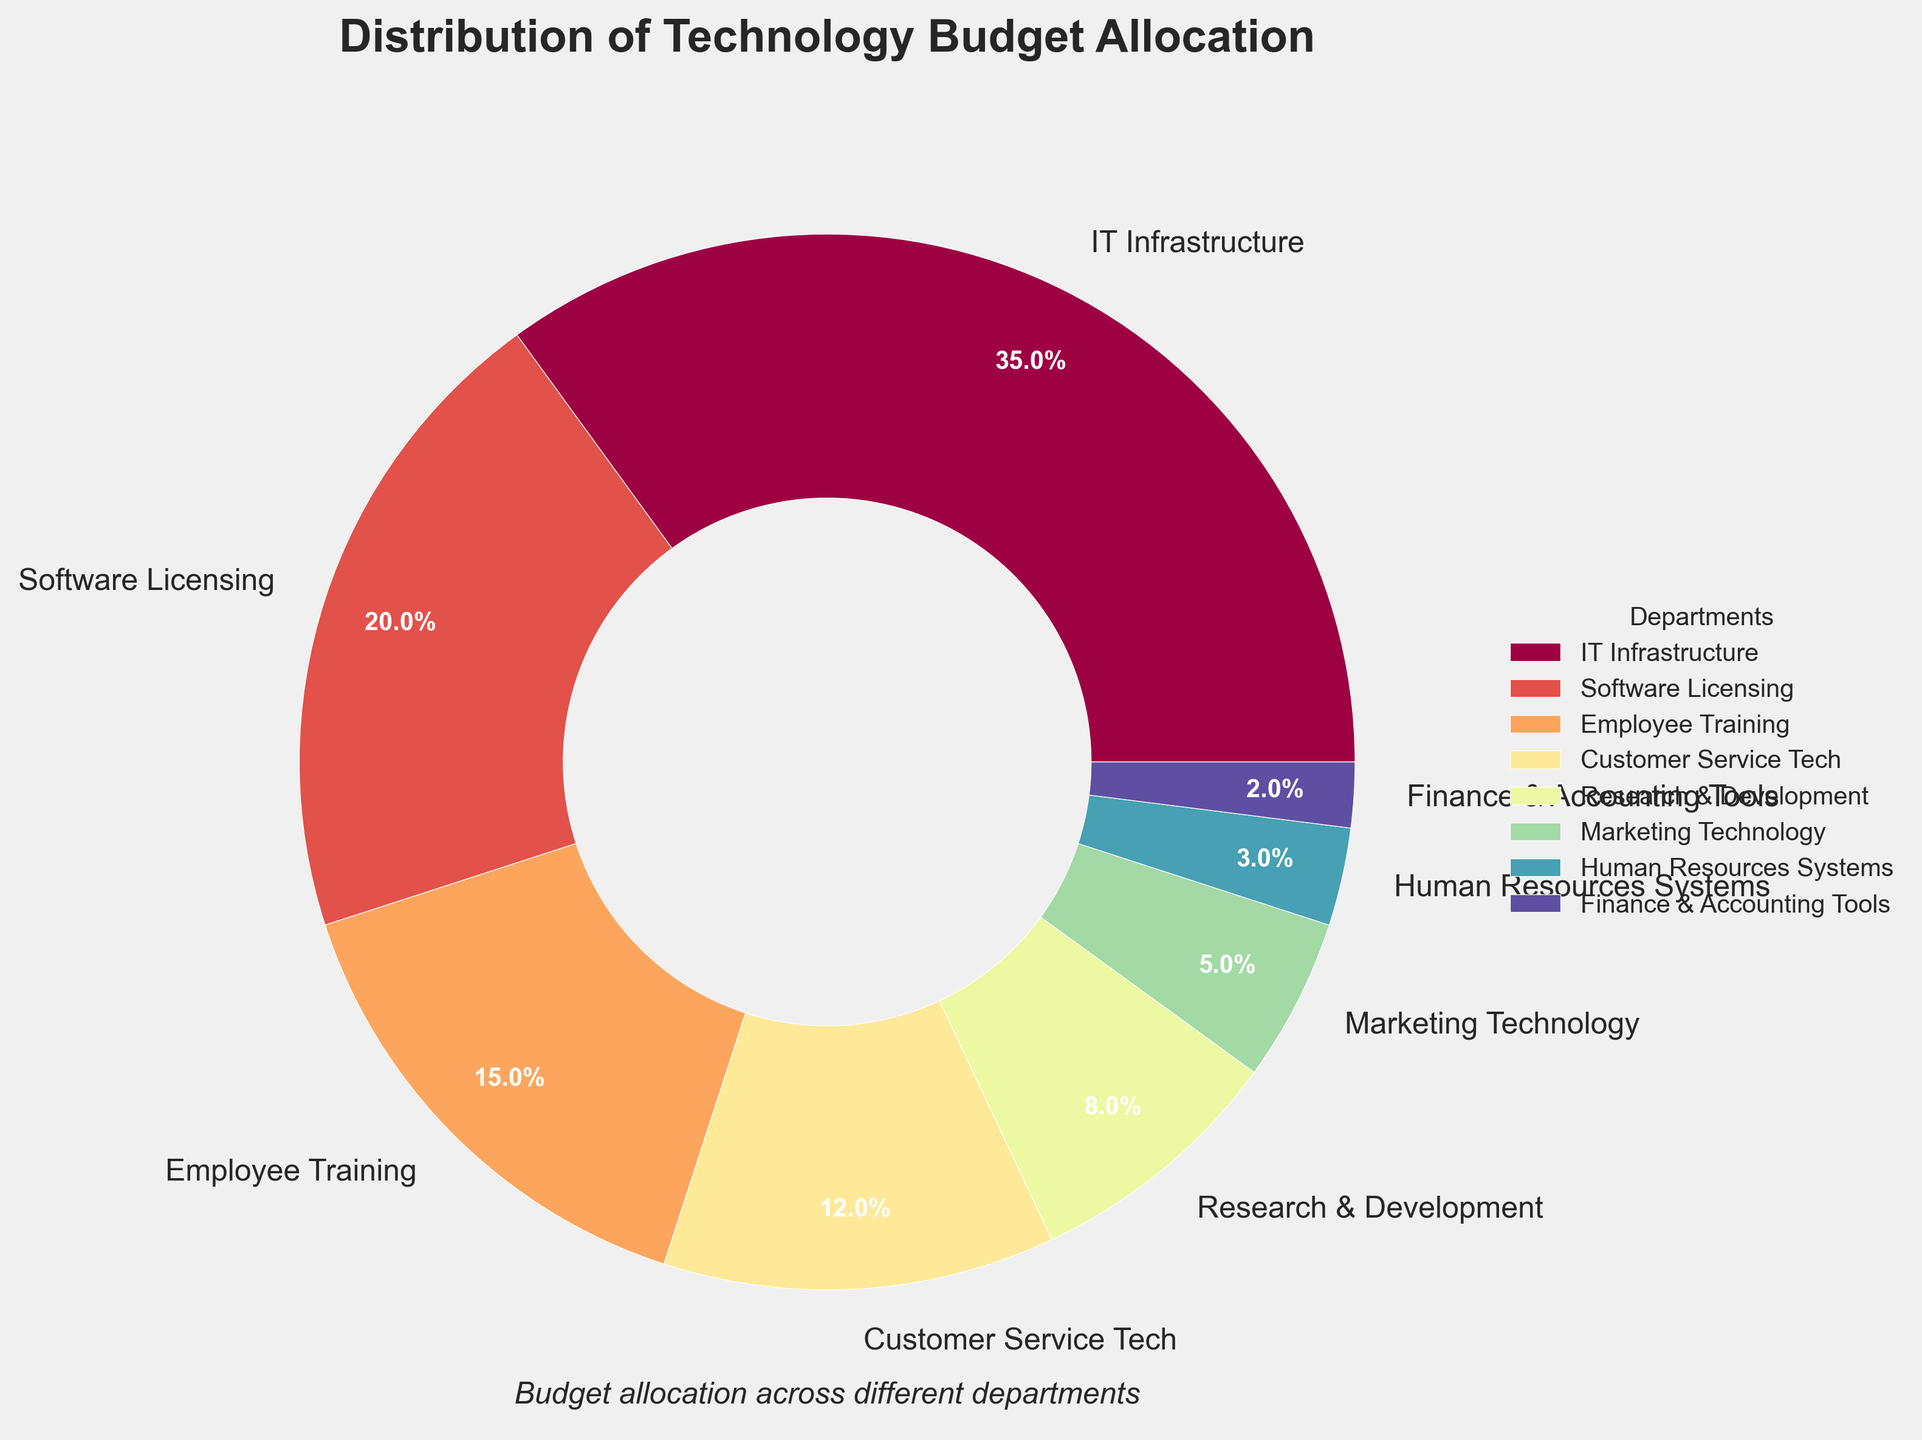What percentage of the budget is allocated to IT Infrastructure? The pie chart shows the budget allocation for each department, with the percentage values labeled on each section. According to the chart, IT Infrastructure has a 35% allocation.
Answer: 35% How does the allocation for Software Licensing compare to Employee Training? The pie chart shows that Software Licensing is allocated 20% of the budget, while Employee Training is allocated 15%. Therefore, Software Licensing receives 5% more of the budget than Employee Training.
Answer: Software Licensing has 5% more Which department has the smallest budget allocation and what is it? By examining the pie chart, the smallest slice corresponds to Finance & Accounting Tools with a 2% allocation.
Answer: Finance & Accounting Tools, 2% What is the combined budget allocation for Human Resources Systems and Finance & Accounting Tools? Human Resources Systems is allocated 3%, and Finance & Accounting Tools is allocated 2%. Adding these together, the combined allocation is 3% + 2% = 5%.
Answer: 5% How much more budget is allocated to Customer Service Tech than Marketing Technology? The pie chart shows that Customer Service Tech has 12% and Marketing Technology has 5%. Thus, Customer Service Tech has 12% - 5% = 7% more of the budget than Marketing Technology.
Answer: 7% If you were to reallocate 3% from IT Infrastructure to Employee Training, what would each of their new allocations be? IT Infrastructure currently has a 35% allocation. Removing 3% from IT Infrastructure would result in a 32% allocation for IT Infrastructure. Employee Training currently has a 15% allocation. Adding 3% to Employee Training would increase its allocation to 18%. Therefore, the new allocations would be IT Infrastructure at 32% and Employee Training at 18%.
Answer: IT Infrastructure: 32%, Employee Training: 18% Of the total budget, which three departments receive the highest allocations and what are their combined percentage? Based on the pie chart, the three departments with the highest allocations are IT Infrastructure (35%), Software Licensing (20%), and Employee Training (15%). The combined allocation is 35% + 20% + 15% = 70%.
Answer: IT Infrastructure, Software Licensing, Employee Training, 70% Is the budget allocation for Research & Development greater than for Marketing Technology? The pie chart shows that Research & Development is allocated 8%, and Marketing Technology is allocated 5%. Since 8% is greater than 5%, Research & Development has a higher budget allocation.
Answer: Yes What is the difference between the highest and the lowest budget allocation? The highest budget allocation is for IT Infrastructure at 35%, and the lowest is for Finance & Accounting Tools at 2%. The difference between these two is 35% - 2% = 33%.
Answer: 33% What is the average budget allocation across all departments? To find the average allocation, sum all the percentages and divide by the number of departments. The total allocation is 35% + 20% + 15% + 12% + 8% + 5% + 3% + 2% = 100%. There are 8 departments, so the average allocation is 100% / 8 = 12.5%.
Answer: 12.5% 